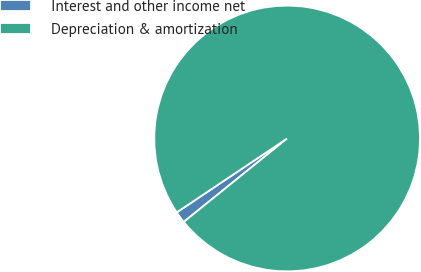Convert chart. <chart><loc_0><loc_0><loc_500><loc_500><pie_chart><fcel>Interest and other income net<fcel>Depreciation & amortization<nl><fcel>1.42%<fcel>98.58%<nl></chart> 